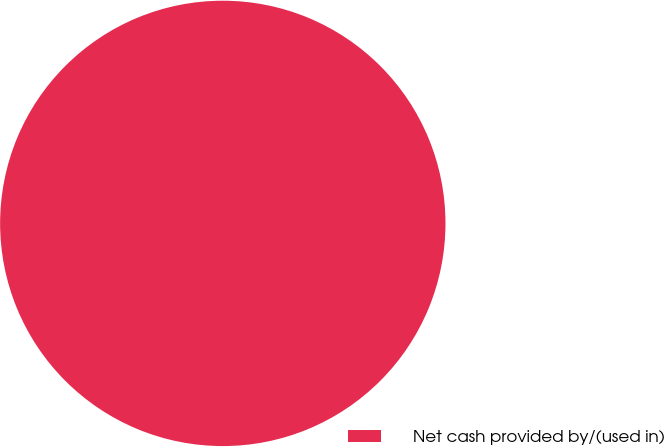<chart> <loc_0><loc_0><loc_500><loc_500><pie_chart><fcel>Net cash provided by/(used in)<nl><fcel>100.0%<nl></chart> 